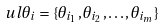<formula> <loc_0><loc_0><loc_500><loc_500>\ u l { \theta } _ { i } = \{ \theta _ { i _ { 1 } } , \theta _ { i _ { 2 } } , \dots , \theta _ { i _ { m } } \}</formula> 